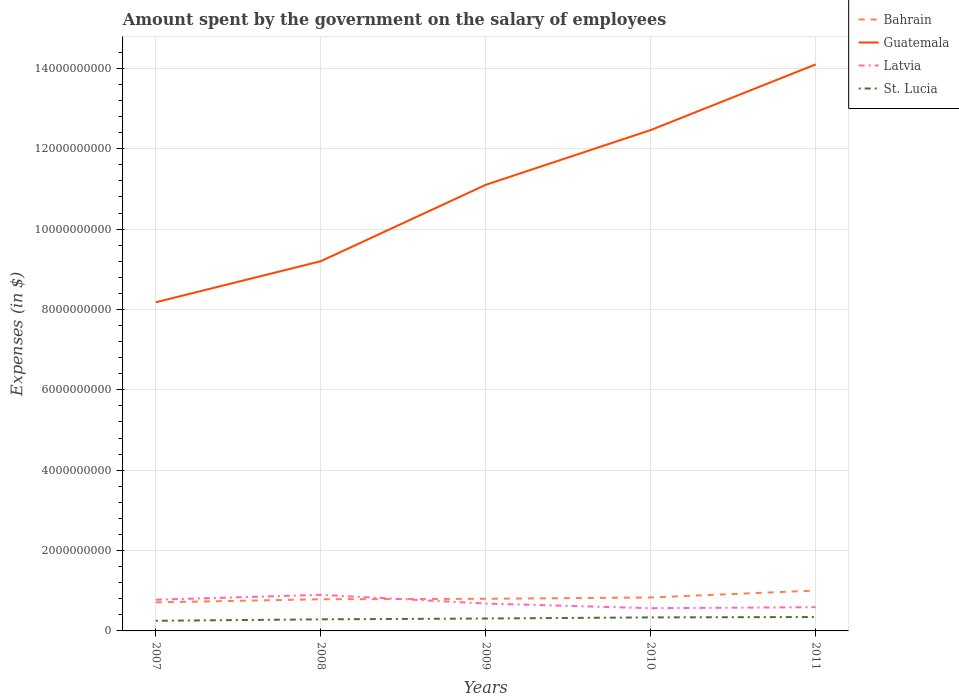Is the number of lines equal to the number of legend labels?
Ensure brevity in your answer.  Yes. Across all years, what is the maximum amount spent on the salary of employees by the government in Latvia?
Offer a terse response. 5.65e+08. What is the total amount spent on the salary of employees by the government in Bahrain in the graph?
Your response must be concise. -3.25e+07. What is the difference between the highest and the second highest amount spent on the salary of employees by the government in St. Lucia?
Give a very brief answer. 9.30e+07. What is the difference between the highest and the lowest amount spent on the salary of employees by the government in St. Lucia?
Your answer should be very brief. 3. What is the difference between two consecutive major ticks on the Y-axis?
Ensure brevity in your answer.  2.00e+09. Are the values on the major ticks of Y-axis written in scientific E-notation?
Give a very brief answer. No. Does the graph contain any zero values?
Keep it short and to the point. No. Where does the legend appear in the graph?
Offer a terse response. Top right. How many legend labels are there?
Provide a short and direct response. 4. How are the legend labels stacked?
Offer a very short reply. Vertical. What is the title of the graph?
Keep it short and to the point. Amount spent by the government on the salary of employees. What is the label or title of the Y-axis?
Provide a succinct answer. Expenses (in $). What is the Expenses (in $) of Bahrain in 2007?
Provide a succinct answer. 7.10e+08. What is the Expenses (in $) of Guatemala in 2007?
Provide a succinct answer. 8.18e+09. What is the Expenses (in $) in Latvia in 2007?
Provide a succinct answer. 7.76e+08. What is the Expenses (in $) in St. Lucia in 2007?
Make the answer very short. 2.52e+08. What is the Expenses (in $) of Bahrain in 2008?
Your answer should be very brief. 7.89e+08. What is the Expenses (in $) in Guatemala in 2008?
Your response must be concise. 9.20e+09. What is the Expenses (in $) of Latvia in 2008?
Your answer should be very brief. 8.98e+08. What is the Expenses (in $) of St. Lucia in 2008?
Your response must be concise. 2.88e+08. What is the Expenses (in $) of Bahrain in 2009?
Ensure brevity in your answer.  8.00e+08. What is the Expenses (in $) in Guatemala in 2009?
Provide a succinct answer. 1.11e+1. What is the Expenses (in $) in Latvia in 2009?
Keep it short and to the point. 6.81e+08. What is the Expenses (in $) in St. Lucia in 2009?
Give a very brief answer. 3.09e+08. What is the Expenses (in $) of Bahrain in 2010?
Offer a very short reply. 8.32e+08. What is the Expenses (in $) of Guatemala in 2010?
Your response must be concise. 1.25e+1. What is the Expenses (in $) of Latvia in 2010?
Offer a very short reply. 5.65e+08. What is the Expenses (in $) of St. Lucia in 2010?
Give a very brief answer. 3.37e+08. What is the Expenses (in $) in Bahrain in 2011?
Keep it short and to the point. 1.00e+09. What is the Expenses (in $) in Guatemala in 2011?
Keep it short and to the point. 1.41e+1. What is the Expenses (in $) of Latvia in 2011?
Provide a short and direct response. 5.91e+08. What is the Expenses (in $) of St. Lucia in 2011?
Provide a succinct answer. 3.45e+08. Across all years, what is the maximum Expenses (in $) in Bahrain?
Make the answer very short. 1.00e+09. Across all years, what is the maximum Expenses (in $) of Guatemala?
Offer a very short reply. 1.41e+1. Across all years, what is the maximum Expenses (in $) in Latvia?
Provide a short and direct response. 8.98e+08. Across all years, what is the maximum Expenses (in $) in St. Lucia?
Make the answer very short. 3.45e+08. Across all years, what is the minimum Expenses (in $) in Bahrain?
Provide a succinct answer. 7.10e+08. Across all years, what is the minimum Expenses (in $) of Guatemala?
Keep it short and to the point. 8.18e+09. Across all years, what is the minimum Expenses (in $) in Latvia?
Your response must be concise. 5.65e+08. Across all years, what is the minimum Expenses (in $) in St. Lucia?
Your answer should be compact. 2.52e+08. What is the total Expenses (in $) of Bahrain in the graph?
Keep it short and to the point. 4.14e+09. What is the total Expenses (in $) of Guatemala in the graph?
Provide a short and direct response. 5.51e+1. What is the total Expenses (in $) of Latvia in the graph?
Give a very brief answer. 3.51e+09. What is the total Expenses (in $) in St. Lucia in the graph?
Provide a succinct answer. 1.53e+09. What is the difference between the Expenses (in $) in Bahrain in 2007 and that in 2008?
Keep it short and to the point. -7.84e+07. What is the difference between the Expenses (in $) in Guatemala in 2007 and that in 2008?
Make the answer very short. -1.02e+09. What is the difference between the Expenses (in $) of Latvia in 2007 and that in 2008?
Offer a very short reply. -1.22e+08. What is the difference between the Expenses (in $) of St. Lucia in 2007 and that in 2008?
Offer a terse response. -3.59e+07. What is the difference between the Expenses (in $) in Bahrain in 2007 and that in 2009?
Provide a short and direct response. -8.97e+07. What is the difference between the Expenses (in $) of Guatemala in 2007 and that in 2009?
Your answer should be compact. -2.92e+09. What is the difference between the Expenses (in $) in Latvia in 2007 and that in 2009?
Offer a very short reply. 9.54e+07. What is the difference between the Expenses (in $) in St. Lucia in 2007 and that in 2009?
Ensure brevity in your answer.  -5.66e+07. What is the difference between the Expenses (in $) in Bahrain in 2007 and that in 2010?
Offer a terse response. -1.22e+08. What is the difference between the Expenses (in $) of Guatemala in 2007 and that in 2010?
Provide a succinct answer. -4.29e+09. What is the difference between the Expenses (in $) of Latvia in 2007 and that in 2010?
Give a very brief answer. 2.11e+08. What is the difference between the Expenses (in $) in St. Lucia in 2007 and that in 2010?
Provide a short and direct response. -8.42e+07. What is the difference between the Expenses (in $) in Bahrain in 2007 and that in 2011?
Offer a terse response. -2.95e+08. What is the difference between the Expenses (in $) in Guatemala in 2007 and that in 2011?
Keep it short and to the point. -5.92e+09. What is the difference between the Expenses (in $) of Latvia in 2007 and that in 2011?
Provide a succinct answer. 1.85e+08. What is the difference between the Expenses (in $) of St. Lucia in 2007 and that in 2011?
Provide a short and direct response. -9.30e+07. What is the difference between the Expenses (in $) of Bahrain in 2008 and that in 2009?
Provide a short and direct response. -1.12e+07. What is the difference between the Expenses (in $) of Guatemala in 2008 and that in 2009?
Keep it short and to the point. -1.90e+09. What is the difference between the Expenses (in $) of Latvia in 2008 and that in 2009?
Ensure brevity in your answer.  2.17e+08. What is the difference between the Expenses (in $) in St. Lucia in 2008 and that in 2009?
Make the answer very short. -2.07e+07. What is the difference between the Expenses (in $) in Bahrain in 2008 and that in 2010?
Ensure brevity in your answer.  -4.38e+07. What is the difference between the Expenses (in $) in Guatemala in 2008 and that in 2010?
Offer a very short reply. -3.26e+09. What is the difference between the Expenses (in $) in Latvia in 2008 and that in 2010?
Ensure brevity in your answer.  3.33e+08. What is the difference between the Expenses (in $) in St. Lucia in 2008 and that in 2010?
Your answer should be very brief. -4.83e+07. What is the difference between the Expenses (in $) in Bahrain in 2008 and that in 2011?
Offer a very short reply. -2.16e+08. What is the difference between the Expenses (in $) of Guatemala in 2008 and that in 2011?
Provide a succinct answer. -4.90e+09. What is the difference between the Expenses (in $) in Latvia in 2008 and that in 2011?
Your answer should be compact. 3.07e+08. What is the difference between the Expenses (in $) of St. Lucia in 2008 and that in 2011?
Your response must be concise. -5.71e+07. What is the difference between the Expenses (in $) in Bahrain in 2009 and that in 2010?
Your response must be concise. -3.25e+07. What is the difference between the Expenses (in $) of Guatemala in 2009 and that in 2010?
Offer a very short reply. -1.36e+09. What is the difference between the Expenses (in $) in Latvia in 2009 and that in 2010?
Keep it short and to the point. 1.16e+08. What is the difference between the Expenses (in $) in St. Lucia in 2009 and that in 2010?
Your response must be concise. -2.76e+07. What is the difference between the Expenses (in $) of Bahrain in 2009 and that in 2011?
Give a very brief answer. -2.05e+08. What is the difference between the Expenses (in $) of Guatemala in 2009 and that in 2011?
Give a very brief answer. -3.00e+09. What is the difference between the Expenses (in $) of Latvia in 2009 and that in 2011?
Offer a terse response. 9.01e+07. What is the difference between the Expenses (in $) of St. Lucia in 2009 and that in 2011?
Offer a very short reply. -3.64e+07. What is the difference between the Expenses (in $) in Bahrain in 2010 and that in 2011?
Your answer should be compact. -1.73e+08. What is the difference between the Expenses (in $) in Guatemala in 2010 and that in 2011?
Provide a short and direct response. -1.63e+09. What is the difference between the Expenses (in $) of Latvia in 2010 and that in 2011?
Ensure brevity in your answer.  -2.55e+07. What is the difference between the Expenses (in $) in St. Lucia in 2010 and that in 2011?
Offer a very short reply. -8.80e+06. What is the difference between the Expenses (in $) of Bahrain in 2007 and the Expenses (in $) of Guatemala in 2008?
Your response must be concise. -8.49e+09. What is the difference between the Expenses (in $) in Bahrain in 2007 and the Expenses (in $) in Latvia in 2008?
Your answer should be very brief. -1.88e+08. What is the difference between the Expenses (in $) of Bahrain in 2007 and the Expenses (in $) of St. Lucia in 2008?
Offer a very short reply. 4.22e+08. What is the difference between the Expenses (in $) in Guatemala in 2007 and the Expenses (in $) in Latvia in 2008?
Provide a short and direct response. 7.28e+09. What is the difference between the Expenses (in $) of Guatemala in 2007 and the Expenses (in $) of St. Lucia in 2008?
Your response must be concise. 7.89e+09. What is the difference between the Expenses (in $) in Latvia in 2007 and the Expenses (in $) in St. Lucia in 2008?
Your response must be concise. 4.88e+08. What is the difference between the Expenses (in $) in Bahrain in 2007 and the Expenses (in $) in Guatemala in 2009?
Offer a terse response. -1.04e+1. What is the difference between the Expenses (in $) in Bahrain in 2007 and the Expenses (in $) in Latvia in 2009?
Offer a very short reply. 2.90e+07. What is the difference between the Expenses (in $) in Bahrain in 2007 and the Expenses (in $) in St. Lucia in 2009?
Your answer should be compact. 4.01e+08. What is the difference between the Expenses (in $) of Guatemala in 2007 and the Expenses (in $) of Latvia in 2009?
Provide a short and direct response. 7.50e+09. What is the difference between the Expenses (in $) in Guatemala in 2007 and the Expenses (in $) in St. Lucia in 2009?
Ensure brevity in your answer.  7.87e+09. What is the difference between the Expenses (in $) in Latvia in 2007 and the Expenses (in $) in St. Lucia in 2009?
Provide a short and direct response. 4.68e+08. What is the difference between the Expenses (in $) of Bahrain in 2007 and the Expenses (in $) of Guatemala in 2010?
Your answer should be compact. -1.18e+1. What is the difference between the Expenses (in $) of Bahrain in 2007 and the Expenses (in $) of Latvia in 2010?
Your response must be concise. 1.45e+08. What is the difference between the Expenses (in $) of Bahrain in 2007 and the Expenses (in $) of St. Lucia in 2010?
Offer a very short reply. 3.74e+08. What is the difference between the Expenses (in $) in Guatemala in 2007 and the Expenses (in $) in Latvia in 2010?
Offer a terse response. 7.61e+09. What is the difference between the Expenses (in $) of Guatemala in 2007 and the Expenses (in $) of St. Lucia in 2010?
Offer a very short reply. 7.84e+09. What is the difference between the Expenses (in $) of Latvia in 2007 and the Expenses (in $) of St. Lucia in 2010?
Provide a short and direct response. 4.40e+08. What is the difference between the Expenses (in $) in Bahrain in 2007 and the Expenses (in $) in Guatemala in 2011?
Your answer should be compact. -1.34e+1. What is the difference between the Expenses (in $) in Bahrain in 2007 and the Expenses (in $) in Latvia in 2011?
Provide a short and direct response. 1.19e+08. What is the difference between the Expenses (in $) of Bahrain in 2007 and the Expenses (in $) of St. Lucia in 2011?
Provide a succinct answer. 3.65e+08. What is the difference between the Expenses (in $) of Guatemala in 2007 and the Expenses (in $) of Latvia in 2011?
Ensure brevity in your answer.  7.59e+09. What is the difference between the Expenses (in $) in Guatemala in 2007 and the Expenses (in $) in St. Lucia in 2011?
Keep it short and to the point. 7.83e+09. What is the difference between the Expenses (in $) in Latvia in 2007 and the Expenses (in $) in St. Lucia in 2011?
Offer a terse response. 4.31e+08. What is the difference between the Expenses (in $) of Bahrain in 2008 and the Expenses (in $) of Guatemala in 2009?
Provide a short and direct response. -1.03e+1. What is the difference between the Expenses (in $) in Bahrain in 2008 and the Expenses (in $) in Latvia in 2009?
Offer a terse response. 1.07e+08. What is the difference between the Expenses (in $) in Bahrain in 2008 and the Expenses (in $) in St. Lucia in 2009?
Ensure brevity in your answer.  4.80e+08. What is the difference between the Expenses (in $) of Guatemala in 2008 and the Expenses (in $) of Latvia in 2009?
Give a very brief answer. 8.52e+09. What is the difference between the Expenses (in $) in Guatemala in 2008 and the Expenses (in $) in St. Lucia in 2009?
Your response must be concise. 8.89e+09. What is the difference between the Expenses (in $) in Latvia in 2008 and the Expenses (in $) in St. Lucia in 2009?
Provide a short and direct response. 5.89e+08. What is the difference between the Expenses (in $) in Bahrain in 2008 and the Expenses (in $) in Guatemala in 2010?
Your response must be concise. -1.17e+1. What is the difference between the Expenses (in $) of Bahrain in 2008 and the Expenses (in $) of Latvia in 2010?
Your answer should be very brief. 2.23e+08. What is the difference between the Expenses (in $) of Bahrain in 2008 and the Expenses (in $) of St. Lucia in 2010?
Offer a very short reply. 4.52e+08. What is the difference between the Expenses (in $) of Guatemala in 2008 and the Expenses (in $) of Latvia in 2010?
Give a very brief answer. 8.64e+09. What is the difference between the Expenses (in $) in Guatemala in 2008 and the Expenses (in $) in St. Lucia in 2010?
Provide a short and direct response. 8.87e+09. What is the difference between the Expenses (in $) of Latvia in 2008 and the Expenses (in $) of St. Lucia in 2010?
Keep it short and to the point. 5.61e+08. What is the difference between the Expenses (in $) in Bahrain in 2008 and the Expenses (in $) in Guatemala in 2011?
Offer a very short reply. -1.33e+1. What is the difference between the Expenses (in $) of Bahrain in 2008 and the Expenses (in $) of Latvia in 2011?
Offer a very short reply. 1.98e+08. What is the difference between the Expenses (in $) of Bahrain in 2008 and the Expenses (in $) of St. Lucia in 2011?
Offer a terse response. 4.43e+08. What is the difference between the Expenses (in $) of Guatemala in 2008 and the Expenses (in $) of Latvia in 2011?
Provide a short and direct response. 8.61e+09. What is the difference between the Expenses (in $) of Guatemala in 2008 and the Expenses (in $) of St. Lucia in 2011?
Provide a succinct answer. 8.86e+09. What is the difference between the Expenses (in $) in Latvia in 2008 and the Expenses (in $) in St. Lucia in 2011?
Your answer should be compact. 5.53e+08. What is the difference between the Expenses (in $) of Bahrain in 2009 and the Expenses (in $) of Guatemala in 2010?
Provide a succinct answer. -1.17e+1. What is the difference between the Expenses (in $) of Bahrain in 2009 and the Expenses (in $) of Latvia in 2010?
Provide a succinct answer. 2.34e+08. What is the difference between the Expenses (in $) of Bahrain in 2009 and the Expenses (in $) of St. Lucia in 2010?
Your answer should be very brief. 4.63e+08. What is the difference between the Expenses (in $) in Guatemala in 2009 and the Expenses (in $) in Latvia in 2010?
Give a very brief answer. 1.05e+1. What is the difference between the Expenses (in $) of Guatemala in 2009 and the Expenses (in $) of St. Lucia in 2010?
Give a very brief answer. 1.08e+1. What is the difference between the Expenses (in $) in Latvia in 2009 and the Expenses (in $) in St. Lucia in 2010?
Give a very brief answer. 3.45e+08. What is the difference between the Expenses (in $) of Bahrain in 2009 and the Expenses (in $) of Guatemala in 2011?
Your response must be concise. -1.33e+1. What is the difference between the Expenses (in $) in Bahrain in 2009 and the Expenses (in $) in Latvia in 2011?
Provide a succinct answer. 2.09e+08. What is the difference between the Expenses (in $) in Bahrain in 2009 and the Expenses (in $) in St. Lucia in 2011?
Make the answer very short. 4.54e+08. What is the difference between the Expenses (in $) in Guatemala in 2009 and the Expenses (in $) in Latvia in 2011?
Your answer should be compact. 1.05e+1. What is the difference between the Expenses (in $) of Guatemala in 2009 and the Expenses (in $) of St. Lucia in 2011?
Make the answer very short. 1.08e+1. What is the difference between the Expenses (in $) of Latvia in 2009 and the Expenses (in $) of St. Lucia in 2011?
Keep it short and to the point. 3.36e+08. What is the difference between the Expenses (in $) in Bahrain in 2010 and the Expenses (in $) in Guatemala in 2011?
Make the answer very short. -1.33e+1. What is the difference between the Expenses (in $) of Bahrain in 2010 and the Expenses (in $) of Latvia in 2011?
Ensure brevity in your answer.  2.41e+08. What is the difference between the Expenses (in $) in Bahrain in 2010 and the Expenses (in $) in St. Lucia in 2011?
Give a very brief answer. 4.87e+08. What is the difference between the Expenses (in $) in Guatemala in 2010 and the Expenses (in $) in Latvia in 2011?
Your answer should be very brief. 1.19e+1. What is the difference between the Expenses (in $) of Guatemala in 2010 and the Expenses (in $) of St. Lucia in 2011?
Offer a terse response. 1.21e+1. What is the difference between the Expenses (in $) in Latvia in 2010 and the Expenses (in $) in St. Lucia in 2011?
Make the answer very short. 2.20e+08. What is the average Expenses (in $) in Bahrain per year?
Your answer should be compact. 8.27e+08. What is the average Expenses (in $) of Guatemala per year?
Provide a short and direct response. 1.10e+1. What is the average Expenses (in $) in Latvia per year?
Ensure brevity in your answer.  7.02e+08. What is the average Expenses (in $) of St. Lucia per year?
Give a very brief answer. 3.06e+08. In the year 2007, what is the difference between the Expenses (in $) in Bahrain and Expenses (in $) in Guatemala?
Provide a succinct answer. -7.47e+09. In the year 2007, what is the difference between the Expenses (in $) of Bahrain and Expenses (in $) of Latvia?
Provide a succinct answer. -6.63e+07. In the year 2007, what is the difference between the Expenses (in $) in Bahrain and Expenses (in $) in St. Lucia?
Offer a terse response. 4.58e+08. In the year 2007, what is the difference between the Expenses (in $) of Guatemala and Expenses (in $) of Latvia?
Provide a succinct answer. 7.40e+09. In the year 2007, what is the difference between the Expenses (in $) in Guatemala and Expenses (in $) in St. Lucia?
Provide a succinct answer. 7.93e+09. In the year 2007, what is the difference between the Expenses (in $) of Latvia and Expenses (in $) of St. Lucia?
Keep it short and to the point. 5.24e+08. In the year 2008, what is the difference between the Expenses (in $) in Bahrain and Expenses (in $) in Guatemala?
Provide a short and direct response. -8.41e+09. In the year 2008, what is the difference between the Expenses (in $) in Bahrain and Expenses (in $) in Latvia?
Keep it short and to the point. -1.09e+08. In the year 2008, what is the difference between the Expenses (in $) of Bahrain and Expenses (in $) of St. Lucia?
Offer a very short reply. 5.00e+08. In the year 2008, what is the difference between the Expenses (in $) of Guatemala and Expenses (in $) of Latvia?
Ensure brevity in your answer.  8.30e+09. In the year 2008, what is the difference between the Expenses (in $) in Guatemala and Expenses (in $) in St. Lucia?
Make the answer very short. 8.91e+09. In the year 2008, what is the difference between the Expenses (in $) in Latvia and Expenses (in $) in St. Lucia?
Provide a short and direct response. 6.10e+08. In the year 2009, what is the difference between the Expenses (in $) in Bahrain and Expenses (in $) in Guatemala?
Give a very brief answer. -1.03e+1. In the year 2009, what is the difference between the Expenses (in $) in Bahrain and Expenses (in $) in Latvia?
Make the answer very short. 1.19e+08. In the year 2009, what is the difference between the Expenses (in $) of Bahrain and Expenses (in $) of St. Lucia?
Offer a very short reply. 4.91e+08. In the year 2009, what is the difference between the Expenses (in $) of Guatemala and Expenses (in $) of Latvia?
Give a very brief answer. 1.04e+1. In the year 2009, what is the difference between the Expenses (in $) of Guatemala and Expenses (in $) of St. Lucia?
Your answer should be compact. 1.08e+1. In the year 2009, what is the difference between the Expenses (in $) of Latvia and Expenses (in $) of St. Lucia?
Offer a very short reply. 3.72e+08. In the year 2010, what is the difference between the Expenses (in $) in Bahrain and Expenses (in $) in Guatemala?
Provide a succinct answer. -1.16e+1. In the year 2010, what is the difference between the Expenses (in $) of Bahrain and Expenses (in $) of Latvia?
Your answer should be very brief. 2.67e+08. In the year 2010, what is the difference between the Expenses (in $) of Bahrain and Expenses (in $) of St. Lucia?
Offer a terse response. 4.96e+08. In the year 2010, what is the difference between the Expenses (in $) of Guatemala and Expenses (in $) of Latvia?
Make the answer very short. 1.19e+1. In the year 2010, what is the difference between the Expenses (in $) of Guatemala and Expenses (in $) of St. Lucia?
Give a very brief answer. 1.21e+1. In the year 2010, what is the difference between the Expenses (in $) in Latvia and Expenses (in $) in St. Lucia?
Provide a short and direct response. 2.29e+08. In the year 2011, what is the difference between the Expenses (in $) in Bahrain and Expenses (in $) in Guatemala?
Your answer should be compact. -1.31e+1. In the year 2011, what is the difference between the Expenses (in $) of Bahrain and Expenses (in $) of Latvia?
Provide a succinct answer. 4.14e+08. In the year 2011, what is the difference between the Expenses (in $) in Bahrain and Expenses (in $) in St. Lucia?
Keep it short and to the point. 6.60e+08. In the year 2011, what is the difference between the Expenses (in $) of Guatemala and Expenses (in $) of Latvia?
Your response must be concise. 1.35e+1. In the year 2011, what is the difference between the Expenses (in $) of Guatemala and Expenses (in $) of St. Lucia?
Keep it short and to the point. 1.38e+1. In the year 2011, what is the difference between the Expenses (in $) of Latvia and Expenses (in $) of St. Lucia?
Provide a succinct answer. 2.46e+08. What is the ratio of the Expenses (in $) in Bahrain in 2007 to that in 2008?
Your answer should be compact. 0.9. What is the ratio of the Expenses (in $) of Guatemala in 2007 to that in 2008?
Give a very brief answer. 0.89. What is the ratio of the Expenses (in $) in Latvia in 2007 to that in 2008?
Your response must be concise. 0.86. What is the ratio of the Expenses (in $) in St. Lucia in 2007 to that in 2008?
Ensure brevity in your answer.  0.88. What is the ratio of the Expenses (in $) of Bahrain in 2007 to that in 2009?
Your response must be concise. 0.89. What is the ratio of the Expenses (in $) of Guatemala in 2007 to that in 2009?
Make the answer very short. 0.74. What is the ratio of the Expenses (in $) of Latvia in 2007 to that in 2009?
Your response must be concise. 1.14. What is the ratio of the Expenses (in $) of St. Lucia in 2007 to that in 2009?
Offer a terse response. 0.82. What is the ratio of the Expenses (in $) of Bahrain in 2007 to that in 2010?
Provide a succinct answer. 0.85. What is the ratio of the Expenses (in $) of Guatemala in 2007 to that in 2010?
Your response must be concise. 0.66. What is the ratio of the Expenses (in $) of Latvia in 2007 to that in 2010?
Ensure brevity in your answer.  1.37. What is the ratio of the Expenses (in $) in St. Lucia in 2007 to that in 2010?
Offer a very short reply. 0.75. What is the ratio of the Expenses (in $) in Bahrain in 2007 to that in 2011?
Provide a succinct answer. 0.71. What is the ratio of the Expenses (in $) in Guatemala in 2007 to that in 2011?
Provide a short and direct response. 0.58. What is the ratio of the Expenses (in $) of Latvia in 2007 to that in 2011?
Ensure brevity in your answer.  1.31. What is the ratio of the Expenses (in $) of St. Lucia in 2007 to that in 2011?
Your answer should be compact. 0.73. What is the ratio of the Expenses (in $) in Guatemala in 2008 to that in 2009?
Provide a succinct answer. 0.83. What is the ratio of the Expenses (in $) of Latvia in 2008 to that in 2009?
Offer a terse response. 1.32. What is the ratio of the Expenses (in $) in St. Lucia in 2008 to that in 2009?
Keep it short and to the point. 0.93. What is the ratio of the Expenses (in $) in Guatemala in 2008 to that in 2010?
Ensure brevity in your answer.  0.74. What is the ratio of the Expenses (in $) of Latvia in 2008 to that in 2010?
Provide a short and direct response. 1.59. What is the ratio of the Expenses (in $) of St. Lucia in 2008 to that in 2010?
Offer a very short reply. 0.86. What is the ratio of the Expenses (in $) of Bahrain in 2008 to that in 2011?
Make the answer very short. 0.78. What is the ratio of the Expenses (in $) in Guatemala in 2008 to that in 2011?
Keep it short and to the point. 0.65. What is the ratio of the Expenses (in $) in Latvia in 2008 to that in 2011?
Provide a succinct answer. 1.52. What is the ratio of the Expenses (in $) in St. Lucia in 2008 to that in 2011?
Your answer should be very brief. 0.83. What is the ratio of the Expenses (in $) of Bahrain in 2009 to that in 2010?
Make the answer very short. 0.96. What is the ratio of the Expenses (in $) in Guatemala in 2009 to that in 2010?
Ensure brevity in your answer.  0.89. What is the ratio of the Expenses (in $) of Latvia in 2009 to that in 2010?
Ensure brevity in your answer.  1.2. What is the ratio of the Expenses (in $) of St. Lucia in 2009 to that in 2010?
Ensure brevity in your answer.  0.92. What is the ratio of the Expenses (in $) in Bahrain in 2009 to that in 2011?
Keep it short and to the point. 0.8. What is the ratio of the Expenses (in $) of Guatemala in 2009 to that in 2011?
Make the answer very short. 0.79. What is the ratio of the Expenses (in $) of Latvia in 2009 to that in 2011?
Your answer should be very brief. 1.15. What is the ratio of the Expenses (in $) of St. Lucia in 2009 to that in 2011?
Provide a succinct answer. 0.89. What is the ratio of the Expenses (in $) in Bahrain in 2010 to that in 2011?
Offer a very short reply. 0.83. What is the ratio of the Expenses (in $) in Guatemala in 2010 to that in 2011?
Offer a very short reply. 0.88. What is the ratio of the Expenses (in $) of Latvia in 2010 to that in 2011?
Make the answer very short. 0.96. What is the ratio of the Expenses (in $) of St. Lucia in 2010 to that in 2011?
Provide a succinct answer. 0.97. What is the difference between the highest and the second highest Expenses (in $) in Bahrain?
Your answer should be compact. 1.73e+08. What is the difference between the highest and the second highest Expenses (in $) of Guatemala?
Make the answer very short. 1.63e+09. What is the difference between the highest and the second highest Expenses (in $) of Latvia?
Make the answer very short. 1.22e+08. What is the difference between the highest and the second highest Expenses (in $) of St. Lucia?
Your answer should be very brief. 8.80e+06. What is the difference between the highest and the lowest Expenses (in $) of Bahrain?
Give a very brief answer. 2.95e+08. What is the difference between the highest and the lowest Expenses (in $) of Guatemala?
Offer a very short reply. 5.92e+09. What is the difference between the highest and the lowest Expenses (in $) in Latvia?
Make the answer very short. 3.33e+08. What is the difference between the highest and the lowest Expenses (in $) of St. Lucia?
Your response must be concise. 9.30e+07. 